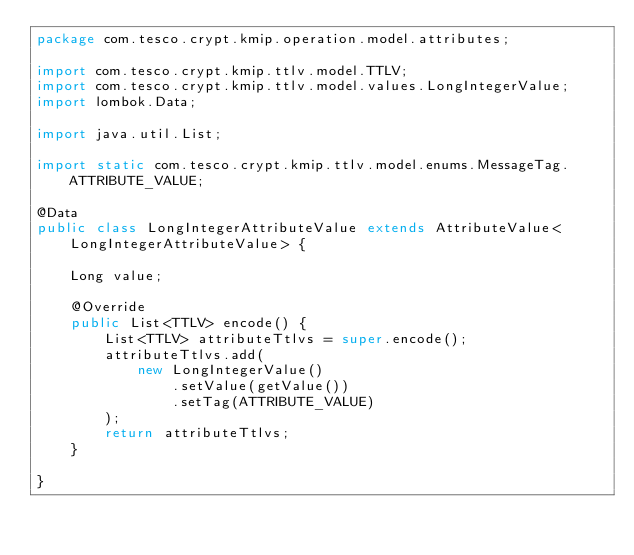<code> <loc_0><loc_0><loc_500><loc_500><_Java_>package com.tesco.crypt.kmip.operation.model.attributes;

import com.tesco.crypt.kmip.ttlv.model.TTLV;
import com.tesco.crypt.kmip.ttlv.model.values.LongIntegerValue;
import lombok.Data;

import java.util.List;

import static com.tesco.crypt.kmip.ttlv.model.enums.MessageTag.ATTRIBUTE_VALUE;

@Data
public class LongIntegerAttributeValue extends AttributeValue<LongIntegerAttributeValue> {

    Long value;

    @Override
    public List<TTLV> encode() {
        List<TTLV> attributeTtlvs = super.encode();
        attributeTtlvs.add(
            new LongIntegerValue()
                .setValue(getValue())
                .setTag(ATTRIBUTE_VALUE)
        );
        return attributeTtlvs;
    }

}
</code> 